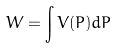<formula> <loc_0><loc_0><loc_500><loc_500>W = \int V ( P ) d P</formula> 